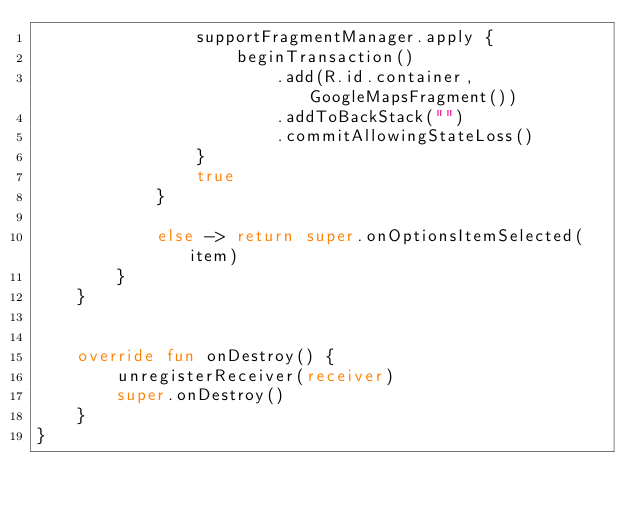Convert code to text. <code><loc_0><loc_0><loc_500><loc_500><_Kotlin_>                supportFragmentManager.apply {
                    beginTransaction()
                        .add(R.id.container, GoogleMapsFragment())
                        .addToBackStack("")
                        .commitAllowingStateLoss()
                }
                true
            }

            else -> return super.onOptionsItemSelected(item)
        }
    }


    override fun onDestroy() {
        unregisterReceiver(receiver)
        super.onDestroy()
    }
}</code> 